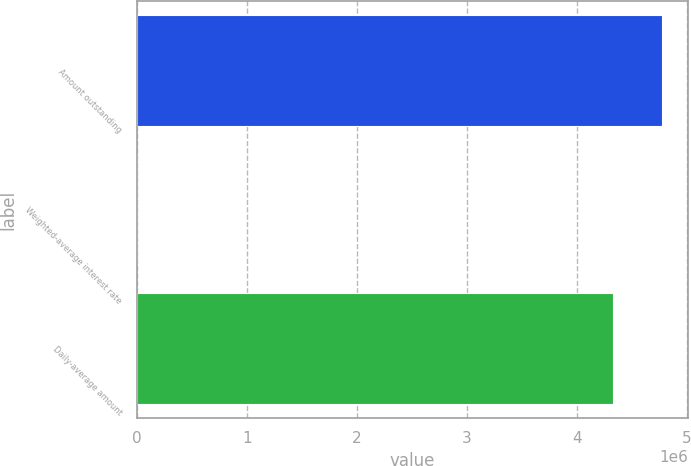Convert chart to OTSL. <chart><loc_0><loc_0><loc_500><loc_500><bar_chart><fcel>Amount outstanding<fcel>Weighted-average interest rate<fcel>Daily-average amount<nl><fcel>4.77504e+06<fcel>0.96<fcel>4.33082e+06<nl></chart> 